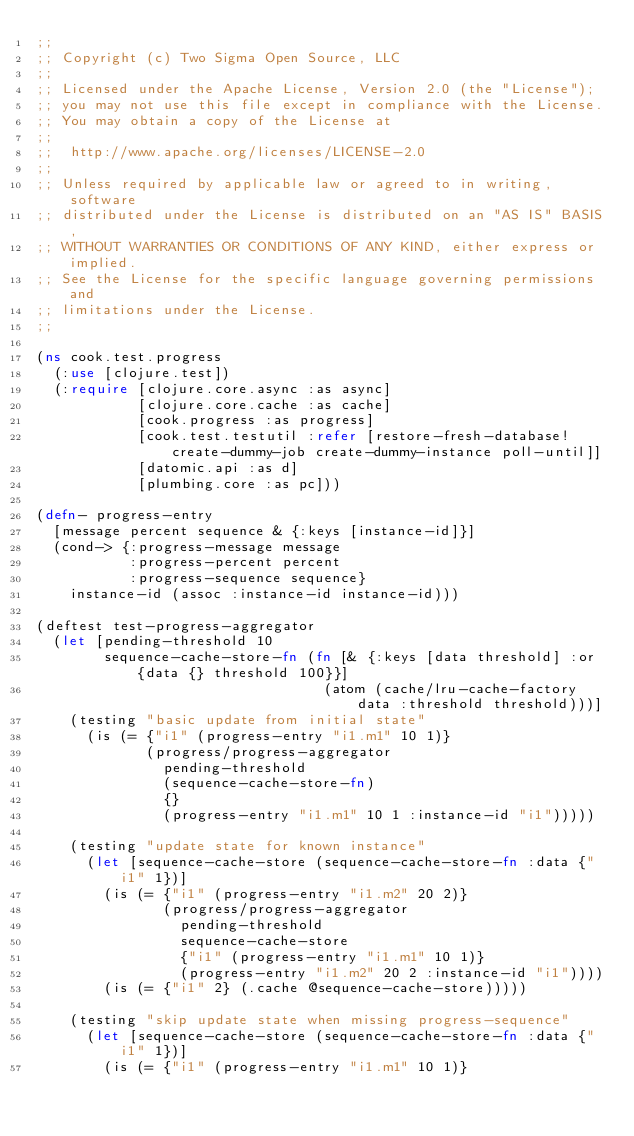Convert code to text. <code><loc_0><loc_0><loc_500><loc_500><_Clojure_>;;
;; Copyright (c) Two Sigma Open Source, LLC
;;
;; Licensed under the Apache License, Version 2.0 (the "License");
;; you may not use this file except in compliance with the License.
;; You may obtain a copy of the License at
;;
;;  http://www.apache.org/licenses/LICENSE-2.0
;;
;; Unless required by applicable law or agreed to in writing, software
;; distributed under the License is distributed on an "AS IS" BASIS,
;; WITHOUT WARRANTIES OR CONDITIONS OF ANY KIND, either express or implied.
;; See the License for the specific language governing permissions and
;; limitations under the License.
;;

(ns cook.test.progress
  (:use [clojure.test])
  (:require [clojure.core.async :as async]
            [clojure.core.cache :as cache]
            [cook.progress :as progress]
            [cook.test.testutil :refer [restore-fresh-database! create-dummy-job create-dummy-instance poll-until]]
            [datomic.api :as d]
            [plumbing.core :as pc]))

(defn- progress-entry
  [message percent sequence & {:keys [instance-id]}]
  (cond-> {:progress-message message
           :progress-percent percent
           :progress-sequence sequence}
    instance-id (assoc :instance-id instance-id)))

(deftest test-progress-aggregator
  (let [pending-threshold 10
        sequence-cache-store-fn (fn [& {:keys [data threshold] :or {data {} threshold 100}}]
                                  (atom (cache/lru-cache-factory data :threshold threshold)))]
    (testing "basic update from initial state"
      (is (= {"i1" (progress-entry "i1.m1" 10 1)}
             (progress/progress-aggregator
               pending-threshold
               (sequence-cache-store-fn)
               {}
               (progress-entry "i1.m1" 10 1 :instance-id "i1")))))

    (testing "update state for known instance"
      (let [sequence-cache-store (sequence-cache-store-fn :data {"i1" 1})]
        (is (= {"i1" (progress-entry "i1.m2" 20 2)}
               (progress/progress-aggregator
                 pending-threshold
                 sequence-cache-store
                 {"i1" (progress-entry "i1.m1" 10 1)}
                 (progress-entry "i1.m2" 20 2 :instance-id "i1"))))
        (is (= {"i1" 2} (.cache @sequence-cache-store)))))

    (testing "skip update state when missing progress-sequence"
      (let [sequence-cache-store (sequence-cache-store-fn :data {"i1" 1})]
        (is (= {"i1" (progress-entry "i1.m1" 10 1)}</code> 